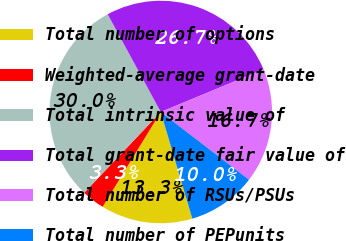<chart> <loc_0><loc_0><loc_500><loc_500><pie_chart><fcel>Total number of options<fcel>Weighted-average grant-date<fcel>Total intrinsic value of<fcel>Total grant-date fair value of<fcel>Total number of RSUs/PSUs<fcel>Total number of PEPunits<nl><fcel>13.33%<fcel>3.33%<fcel>30.0%<fcel>26.67%<fcel>16.67%<fcel>10.0%<nl></chart> 